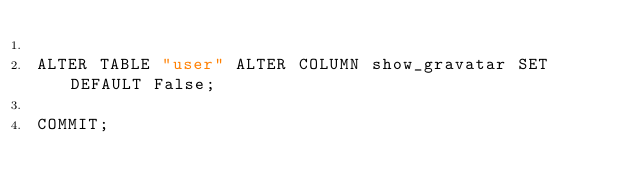<code> <loc_0><loc_0><loc_500><loc_500><_SQL_>
ALTER TABLE "user" ALTER COLUMN show_gravatar SET DEFAULT False;

COMMIT;
</code> 